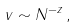Convert formula to latex. <formula><loc_0><loc_0><loc_500><loc_500>v \sim N ^ { - z } \, ,</formula> 